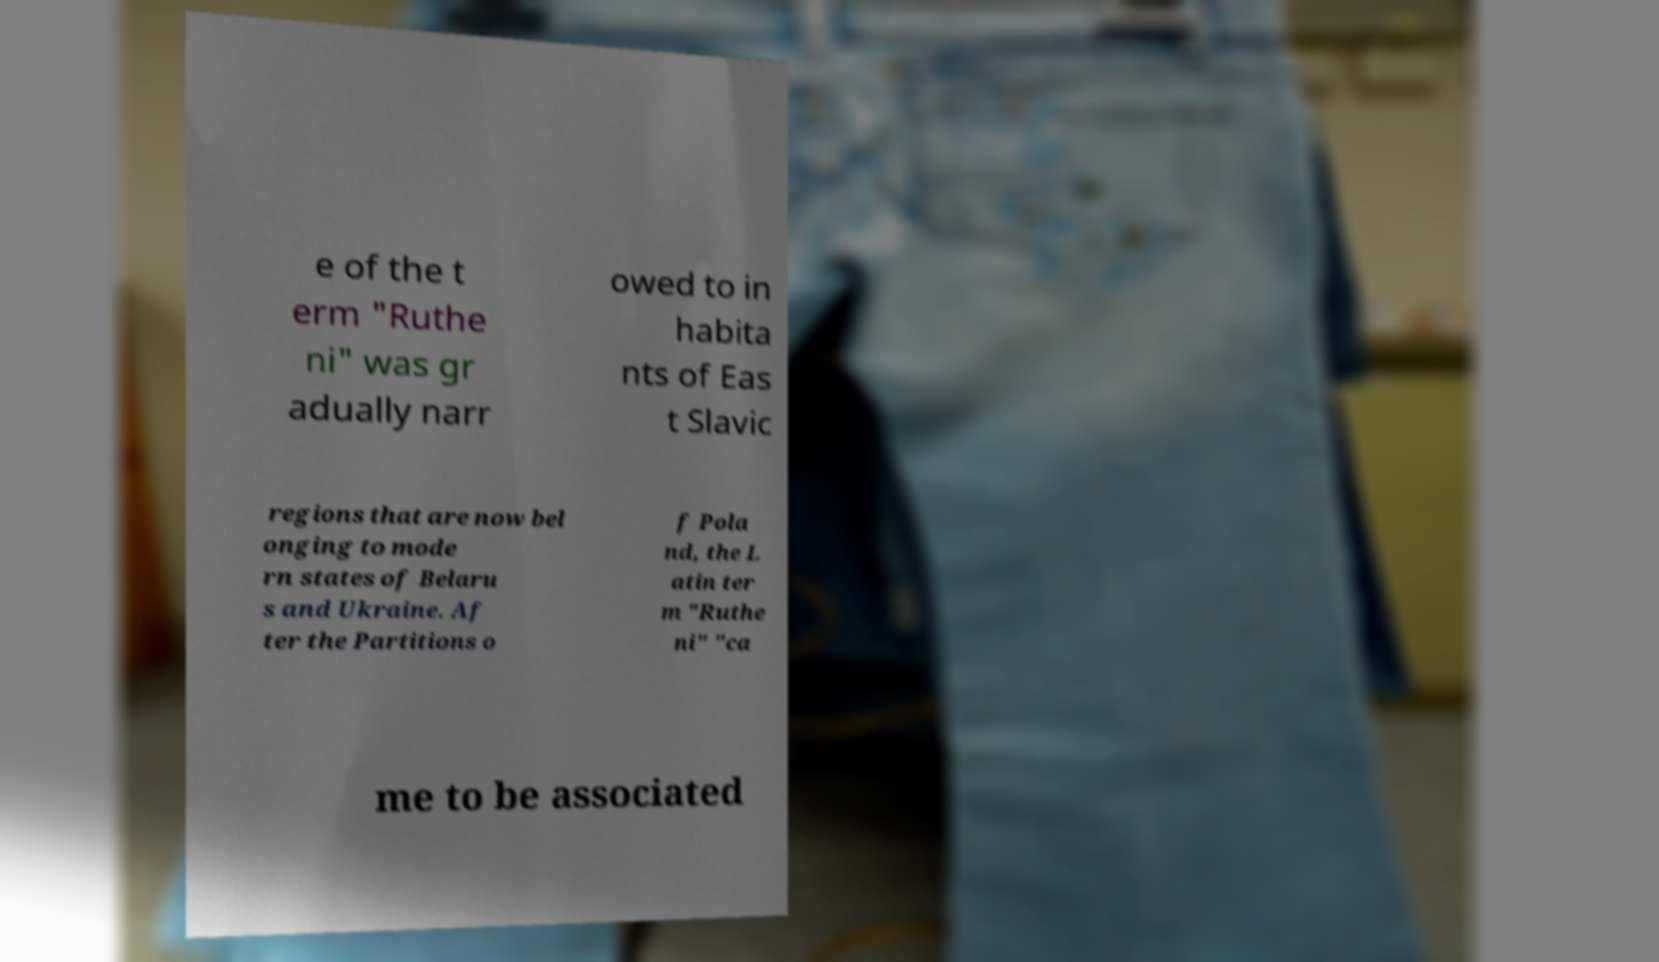For documentation purposes, I need the text within this image transcribed. Could you provide that? e of the t erm "Ruthe ni" was gr adually narr owed to in habita nts of Eas t Slavic regions that are now bel onging to mode rn states of Belaru s and Ukraine. Af ter the Partitions o f Pola nd, the L atin ter m "Ruthe ni" "ca me to be associated 